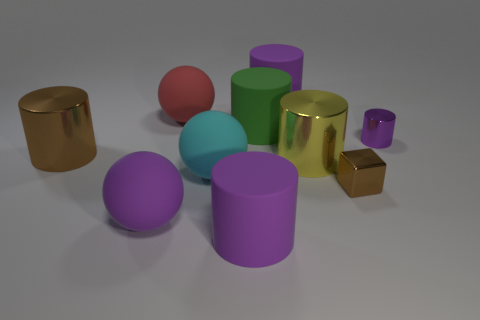What shape is the brown object that is in front of the large cyan thing that is to the left of the tiny cylinder?
Provide a short and direct response. Cube. Are there any big brown things that have the same shape as the cyan matte thing?
Offer a very short reply. No. How many red rubber objects are there?
Your answer should be very brief. 1. Does the purple cylinder behind the small purple shiny object have the same material as the brown cylinder?
Keep it short and to the point. No. Is there a cyan ball of the same size as the green rubber cylinder?
Provide a succinct answer. Yes. Do the purple shiny thing and the brown shiny object that is in front of the cyan rubber object have the same shape?
Your answer should be very brief. No. Is there a shiny cylinder on the left side of the purple cylinder that is on the right side of the purple matte cylinder that is behind the big red thing?
Offer a very short reply. Yes. What size is the brown block?
Provide a short and direct response. Small. What number of other things are there of the same color as the tiny cube?
Give a very brief answer. 1. There is a purple matte object behind the large brown metal thing; is it the same shape as the green thing?
Keep it short and to the point. Yes. 